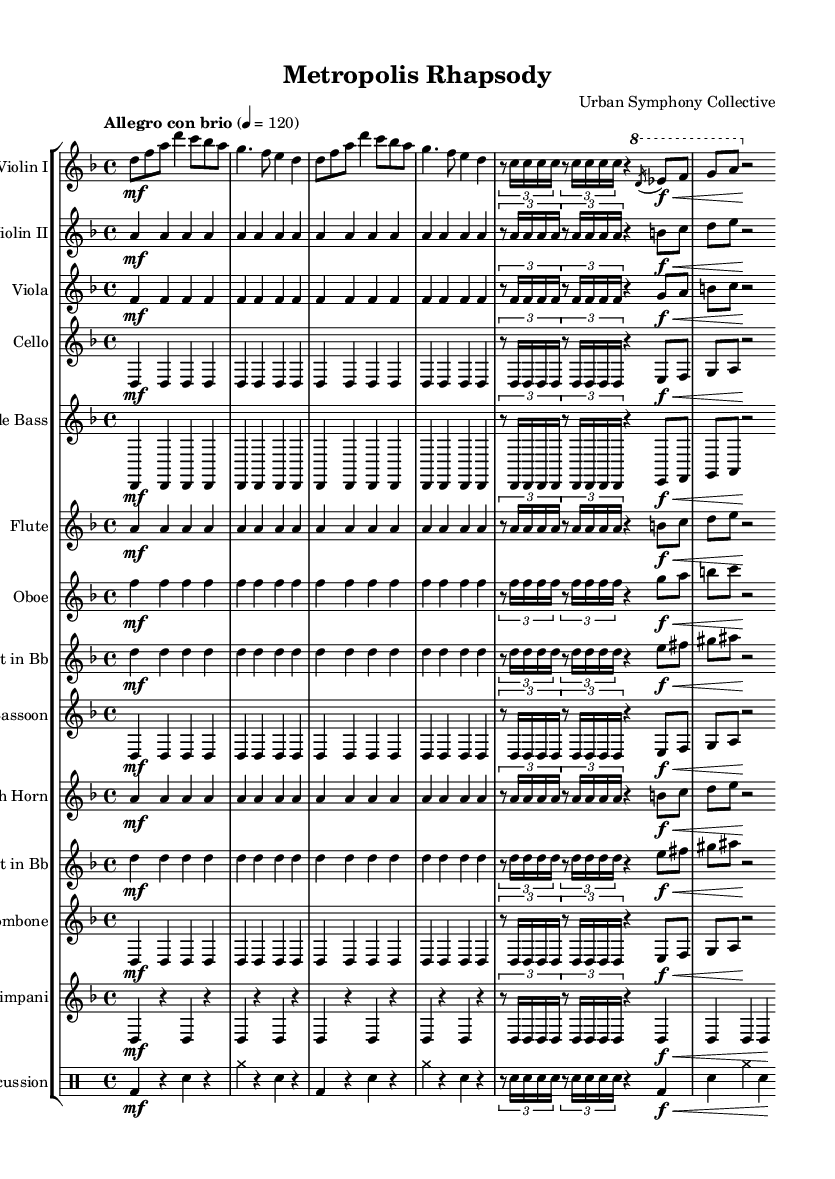What is the key signature of this music? The key signature is D minor, as indicated by the presence of one flat (B flat) and the context of the key signature defined in the global block.
Answer: D minor What is the time signature of this music? The time signature is 4/4, shown at the beginning of the score, indicating four beats per measure with a quarter note receiving one beat.
Answer: 4/4 What is the tempo marking of this piece? The tempo marking is "Allegro con brio," which indicates a lively tempo with energy, found in the global block at the beginning of the score.
Answer: Allegro con brio How many main themes are used in the composition? There are two main themes: Theme A and Theme B, identified explicitly in the score with their respective musical sections labeled at the beginning of each.
Answer: Two What instruments are featured in this symphony? The symphony features strings (violin, viola, cello, double bass), woodwinds (flute, oboe, clarinet, bassoon), brass (horn, trumpet, trombone), timpani, and percussion, as listed in the score section labeled 'score'.
Answer: Strings, woodwinds, brass, timpani, percussion Which section uses a passage in the high register? The flute parts prominently feature high pitches, especially in the repeated notes and flourishes, which can be visually assessed in the sheet music where the flute is indicated with notes placed higher on the staff.
Answer: Flute 